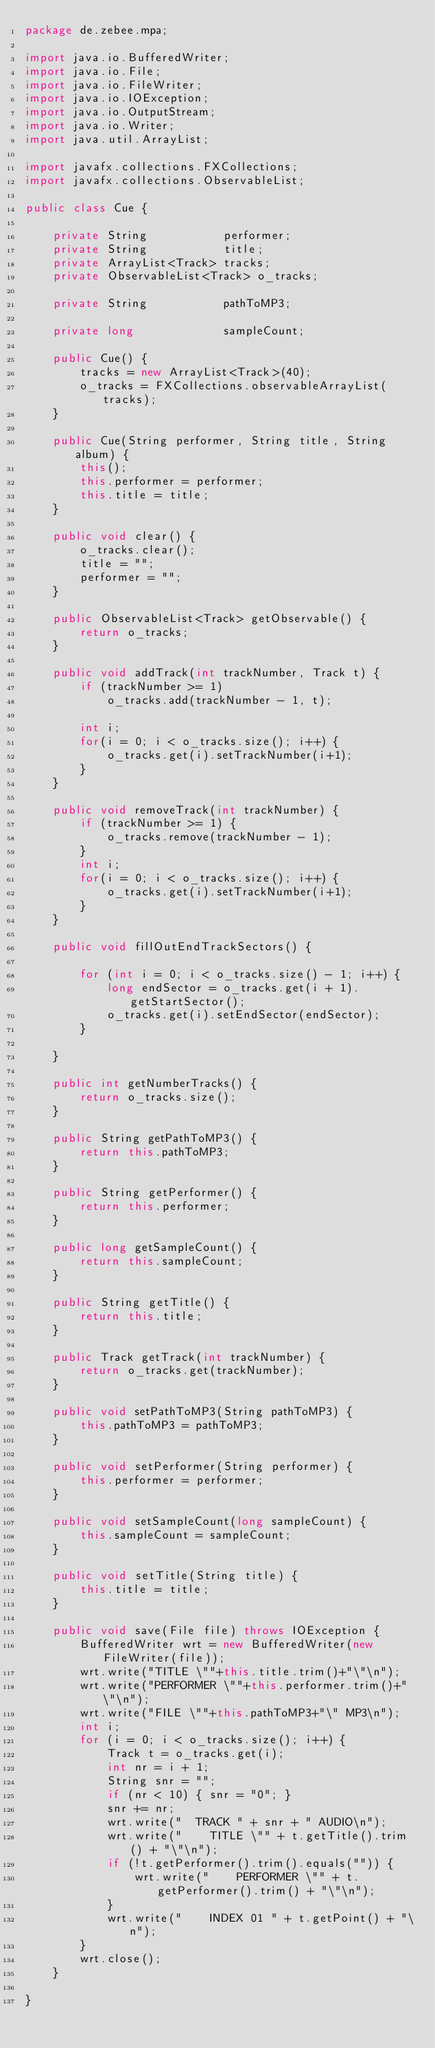Convert code to text. <code><loc_0><loc_0><loc_500><loc_500><_Java_>package de.zebee.mpa;

import java.io.BufferedWriter;
import java.io.File;
import java.io.FileWriter;
import java.io.IOException;
import java.io.OutputStream;
import java.io.Writer;
import java.util.ArrayList;

import javafx.collections.FXCollections;
import javafx.collections.ObservableList;

public class Cue {

    private String           performer;
    private String           title;
    private ArrayList<Track> tracks;
    private ObservableList<Track> o_tracks;

    private String           pathToMP3;

    private long             sampleCount;

    public Cue() {
        tracks = new ArrayList<Track>(40);
        o_tracks = FXCollections.observableArrayList(tracks);
    }

    public Cue(String performer, String title, String album) {
        this();
        this.performer = performer;
        this.title = title;
    }
    
    public void clear() {
    	o_tracks.clear();
    	title = "";
    	performer = "";
    }
    
    public ObservableList<Track> getObservable() {
    	return o_tracks;
    }

    public void addTrack(int trackNumber, Track t) {
        if (trackNumber >= 1)
            o_tracks.add(trackNumber - 1, t);
        
        int i;
        for(i = 0; i < o_tracks.size(); i++) {
        	o_tracks.get(i).setTrackNumber(i+1);
        }
    }
    
    public void removeTrack(int trackNumber) {
    	if (trackNumber >= 1) {
    		o_tracks.remove(trackNumber - 1);
    	}
        int i;
        for(i = 0; i < o_tracks.size(); i++) {
        	o_tracks.get(i).setTrackNumber(i+1);
        }
    }

    public void fillOutEndTrackSectors() {

        for (int i = 0; i < o_tracks.size() - 1; i++) {
            long endSector = o_tracks.get(i + 1).getStartSector();
            o_tracks.get(i).setEndSector(endSector);
        }

    }

    public int getNumberTracks() {
        return o_tracks.size();
    }

    public String getPathToMP3() {
        return this.pathToMP3;
    }

    public String getPerformer() {
        return this.performer;
    }

    public long getSampleCount() {
        return this.sampleCount;
    }

    public String getTitle() {
        return this.title;
    }

    public Track getTrack(int trackNumber) {
        return o_tracks.get(trackNumber);
    }

    public void setPathToMP3(String pathToMP3) {
        this.pathToMP3 = pathToMP3;
    }

    public void setPerformer(String performer) {
        this.performer = performer;
    }

    public void setSampleCount(long sampleCount) {
        this.sampleCount = sampleCount;
    }

    public void setTitle(String title) {
        this.title = title;
    }

	public void save(File file) throws IOException {
		BufferedWriter wrt = new BufferedWriter(new FileWriter(file));
		wrt.write("TITLE \""+this.title.trim()+"\"\n");
		wrt.write("PERFORMER \""+this.performer.trim()+"\"\n");
		wrt.write("FILE \""+this.pathToMP3+"\" MP3\n");
		int i;
		for (i = 0; i < o_tracks.size(); i++) {
			Track t = o_tracks.get(i);
			int nr = i + 1;
			String snr = "";
			if (nr < 10) { snr = "0"; }
			snr += nr;
			wrt.write("  TRACK " + snr + " AUDIO\n");
			wrt.write("    TITLE \"" + t.getTitle().trim() + "\"\n");
			if (!t.getPerformer().trim().equals("")) {
				wrt.write("    PERFORMER \"" + t.getPerformer().trim() + "\"\n");
			}
			wrt.write("    INDEX 01 " + t.getPoint() + "\n");
		}
		wrt.close();
	}

}
</code> 